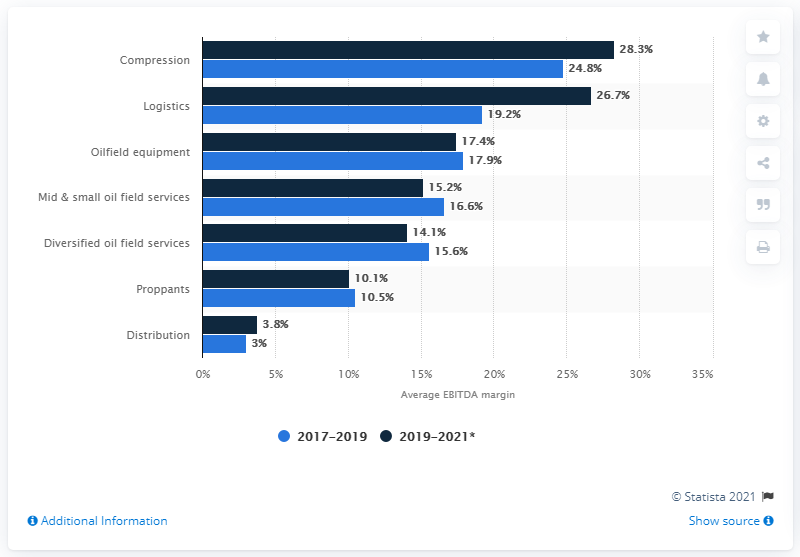Point out several critical features in this image. The highest bar in the chart is 28.3%. Our EBITDA margin is expected to be between 26.7% in 2019 and 2021, with an anticipated increase over the forecast period. The average EBITDA margin from 2017 to 2019 was 19.2%. The combined percentage for proppants and distribution from 2017 to 2019 was 13.5%. 